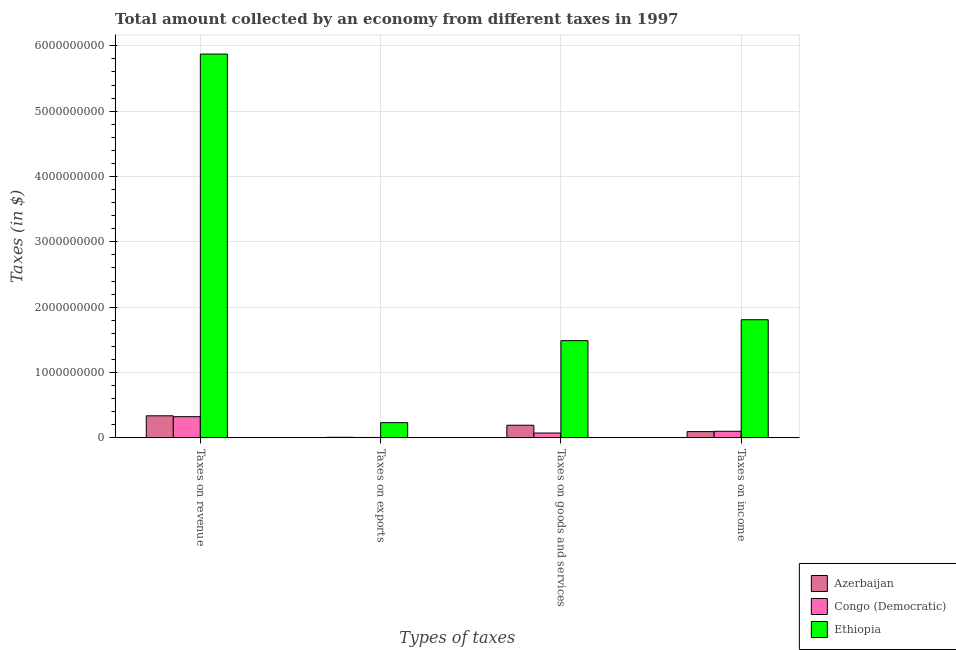How many different coloured bars are there?
Give a very brief answer. 3. Are the number of bars per tick equal to the number of legend labels?
Keep it short and to the point. Yes. Are the number of bars on each tick of the X-axis equal?
Your answer should be compact. Yes. How many bars are there on the 3rd tick from the right?
Your response must be concise. 3. What is the label of the 1st group of bars from the left?
Ensure brevity in your answer.  Taxes on revenue. What is the amount collected as tax on goods in Azerbaijan?
Give a very brief answer. 1.94e+08. Across all countries, what is the maximum amount collected as tax on income?
Make the answer very short. 1.81e+09. Across all countries, what is the minimum amount collected as tax on revenue?
Make the answer very short. 3.24e+08. In which country was the amount collected as tax on revenue maximum?
Ensure brevity in your answer.  Ethiopia. In which country was the amount collected as tax on exports minimum?
Offer a very short reply. Congo (Democratic). What is the total amount collected as tax on goods in the graph?
Provide a short and direct response. 1.76e+09. What is the difference between the amount collected as tax on revenue in Congo (Democratic) and that in Ethiopia?
Your answer should be compact. -5.55e+09. What is the difference between the amount collected as tax on goods in Azerbaijan and the amount collected as tax on exports in Ethiopia?
Your answer should be compact. -3.91e+07. What is the average amount collected as tax on goods per country?
Offer a terse response. 5.85e+08. What is the difference between the amount collected as tax on revenue and amount collected as tax on income in Ethiopia?
Provide a short and direct response. 4.07e+09. In how many countries, is the amount collected as tax on exports greater than 3600000000 $?
Keep it short and to the point. 0. What is the ratio of the amount collected as tax on income in Azerbaijan to that in Congo (Democratic)?
Ensure brevity in your answer.  0.95. Is the amount collected as tax on goods in Congo (Democratic) less than that in Azerbaijan?
Provide a short and direct response. Yes. What is the difference between the highest and the second highest amount collected as tax on goods?
Ensure brevity in your answer.  1.29e+09. What is the difference between the highest and the lowest amount collected as tax on exports?
Provide a short and direct response. 2.26e+08. Is the sum of the amount collected as tax on goods in Congo (Democratic) and Azerbaijan greater than the maximum amount collected as tax on exports across all countries?
Your response must be concise. Yes. Is it the case that in every country, the sum of the amount collected as tax on income and amount collected as tax on revenue is greater than the sum of amount collected as tax on exports and amount collected as tax on goods?
Provide a succinct answer. Yes. What does the 2nd bar from the left in Taxes on goods and services represents?
Your response must be concise. Congo (Democratic). What does the 2nd bar from the right in Taxes on exports represents?
Ensure brevity in your answer.  Congo (Democratic). How many bars are there?
Make the answer very short. 12. Does the graph contain any zero values?
Your response must be concise. No. What is the title of the graph?
Ensure brevity in your answer.  Total amount collected by an economy from different taxes in 1997. Does "Mongolia" appear as one of the legend labels in the graph?
Offer a very short reply. No. What is the label or title of the X-axis?
Provide a short and direct response. Types of taxes. What is the label or title of the Y-axis?
Offer a terse response. Taxes (in $). What is the Taxes (in $) of Azerbaijan in Taxes on revenue?
Your answer should be very brief. 3.38e+08. What is the Taxes (in $) of Congo (Democratic) in Taxes on revenue?
Your response must be concise. 3.24e+08. What is the Taxes (in $) in Ethiopia in Taxes on revenue?
Offer a terse response. 5.87e+09. What is the Taxes (in $) of Azerbaijan in Taxes on exports?
Give a very brief answer. 9.16e+06. What is the Taxes (in $) in Congo (Democratic) in Taxes on exports?
Ensure brevity in your answer.  6.24e+06. What is the Taxes (in $) of Ethiopia in Taxes on exports?
Make the answer very short. 2.33e+08. What is the Taxes (in $) in Azerbaijan in Taxes on goods and services?
Your answer should be compact. 1.94e+08. What is the Taxes (in $) of Congo (Democratic) in Taxes on goods and services?
Offer a very short reply. 7.41e+07. What is the Taxes (in $) of Ethiopia in Taxes on goods and services?
Your answer should be compact. 1.49e+09. What is the Taxes (in $) in Azerbaijan in Taxes on income?
Make the answer very short. 9.60e+07. What is the Taxes (in $) in Congo (Democratic) in Taxes on income?
Your answer should be compact. 1.01e+08. What is the Taxes (in $) in Ethiopia in Taxes on income?
Your answer should be compact. 1.81e+09. Across all Types of taxes, what is the maximum Taxes (in $) of Azerbaijan?
Keep it short and to the point. 3.38e+08. Across all Types of taxes, what is the maximum Taxes (in $) in Congo (Democratic)?
Give a very brief answer. 3.24e+08. Across all Types of taxes, what is the maximum Taxes (in $) in Ethiopia?
Your answer should be very brief. 5.87e+09. Across all Types of taxes, what is the minimum Taxes (in $) in Azerbaijan?
Provide a succinct answer. 9.16e+06. Across all Types of taxes, what is the minimum Taxes (in $) in Congo (Democratic)?
Provide a succinct answer. 6.24e+06. Across all Types of taxes, what is the minimum Taxes (in $) in Ethiopia?
Your answer should be very brief. 2.33e+08. What is the total Taxes (in $) in Azerbaijan in the graph?
Make the answer very short. 6.36e+08. What is the total Taxes (in $) of Congo (Democratic) in the graph?
Make the answer very short. 5.05e+08. What is the total Taxes (in $) of Ethiopia in the graph?
Provide a short and direct response. 9.40e+09. What is the difference between the Taxes (in $) of Azerbaijan in Taxes on revenue and that in Taxes on exports?
Your response must be concise. 3.29e+08. What is the difference between the Taxes (in $) in Congo (Democratic) in Taxes on revenue and that in Taxes on exports?
Your response must be concise. 3.18e+08. What is the difference between the Taxes (in $) of Ethiopia in Taxes on revenue and that in Taxes on exports?
Provide a succinct answer. 5.64e+09. What is the difference between the Taxes (in $) of Azerbaijan in Taxes on revenue and that in Taxes on goods and services?
Provide a short and direct response. 1.44e+08. What is the difference between the Taxes (in $) of Congo (Democratic) in Taxes on revenue and that in Taxes on goods and services?
Ensure brevity in your answer.  2.50e+08. What is the difference between the Taxes (in $) of Ethiopia in Taxes on revenue and that in Taxes on goods and services?
Your response must be concise. 4.39e+09. What is the difference between the Taxes (in $) of Azerbaijan in Taxes on revenue and that in Taxes on income?
Make the answer very short. 2.42e+08. What is the difference between the Taxes (in $) in Congo (Democratic) in Taxes on revenue and that in Taxes on income?
Your answer should be compact. 2.24e+08. What is the difference between the Taxes (in $) of Ethiopia in Taxes on revenue and that in Taxes on income?
Keep it short and to the point. 4.07e+09. What is the difference between the Taxes (in $) of Azerbaijan in Taxes on exports and that in Taxes on goods and services?
Your answer should be very brief. -1.84e+08. What is the difference between the Taxes (in $) of Congo (Democratic) in Taxes on exports and that in Taxes on goods and services?
Provide a succinct answer. -6.78e+07. What is the difference between the Taxes (in $) of Ethiopia in Taxes on exports and that in Taxes on goods and services?
Ensure brevity in your answer.  -1.26e+09. What is the difference between the Taxes (in $) in Azerbaijan in Taxes on exports and that in Taxes on income?
Offer a terse response. -8.68e+07. What is the difference between the Taxes (in $) in Congo (Democratic) in Taxes on exports and that in Taxes on income?
Provide a short and direct response. -9.44e+07. What is the difference between the Taxes (in $) in Ethiopia in Taxes on exports and that in Taxes on income?
Make the answer very short. -1.58e+09. What is the difference between the Taxes (in $) of Azerbaijan in Taxes on goods and services and that in Taxes on income?
Make the answer very short. 9.75e+07. What is the difference between the Taxes (in $) in Congo (Democratic) in Taxes on goods and services and that in Taxes on income?
Your response must be concise. -2.66e+07. What is the difference between the Taxes (in $) in Ethiopia in Taxes on goods and services and that in Taxes on income?
Your response must be concise. -3.20e+08. What is the difference between the Taxes (in $) in Azerbaijan in Taxes on revenue and the Taxes (in $) in Congo (Democratic) in Taxes on exports?
Ensure brevity in your answer.  3.32e+08. What is the difference between the Taxes (in $) in Azerbaijan in Taxes on revenue and the Taxes (in $) in Ethiopia in Taxes on exports?
Give a very brief answer. 1.05e+08. What is the difference between the Taxes (in $) in Congo (Democratic) in Taxes on revenue and the Taxes (in $) in Ethiopia in Taxes on exports?
Provide a succinct answer. 9.17e+07. What is the difference between the Taxes (in $) of Azerbaijan in Taxes on revenue and the Taxes (in $) of Congo (Democratic) in Taxes on goods and services?
Offer a terse response. 2.64e+08. What is the difference between the Taxes (in $) of Azerbaijan in Taxes on revenue and the Taxes (in $) of Ethiopia in Taxes on goods and services?
Provide a short and direct response. -1.15e+09. What is the difference between the Taxes (in $) of Congo (Democratic) in Taxes on revenue and the Taxes (in $) of Ethiopia in Taxes on goods and services?
Your answer should be compact. -1.16e+09. What is the difference between the Taxes (in $) of Azerbaijan in Taxes on revenue and the Taxes (in $) of Congo (Democratic) in Taxes on income?
Offer a very short reply. 2.37e+08. What is the difference between the Taxes (in $) of Azerbaijan in Taxes on revenue and the Taxes (in $) of Ethiopia in Taxes on income?
Ensure brevity in your answer.  -1.47e+09. What is the difference between the Taxes (in $) in Congo (Democratic) in Taxes on revenue and the Taxes (in $) in Ethiopia in Taxes on income?
Give a very brief answer. -1.48e+09. What is the difference between the Taxes (in $) of Azerbaijan in Taxes on exports and the Taxes (in $) of Congo (Democratic) in Taxes on goods and services?
Keep it short and to the point. -6.49e+07. What is the difference between the Taxes (in $) in Azerbaijan in Taxes on exports and the Taxes (in $) in Ethiopia in Taxes on goods and services?
Make the answer very short. -1.48e+09. What is the difference between the Taxes (in $) in Congo (Democratic) in Taxes on exports and the Taxes (in $) in Ethiopia in Taxes on goods and services?
Ensure brevity in your answer.  -1.48e+09. What is the difference between the Taxes (in $) of Azerbaijan in Taxes on exports and the Taxes (in $) of Congo (Democratic) in Taxes on income?
Keep it short and to the point. -9.15e+07. What is the difference between the Taxes (in $) of Azerbaijan in Taxes on exports and the Taxes (in $) of Ethiopia in Taxes on income?
Your answer should be compact. -1.80e+09. What is the difference between the Taxes (in $) in Congo (Democratic) in Taxes on exports and the Taxes (in $) in Ethiopia in Taxes on income?
Your answer should be compact. -1.80e+09. What is the difference between the Taxes (in $) of Azerbaijan in Taxes on goods and services and the Taxes (in $) of Congo (Democratic) in Taxes on income?
Ensure brevity in your answer.  9.28e+07. What is the difference between the Taxes (in $) of Azerbaijan in Taxes on goods and services and the Taxes (in $) of Ethiopia in Taxes on income?
Make the answer very short. -1.61e+09. What is the difference between the Taxes (in $) in Congo (Democratic) in Taxes on goods and services and the Taxes (in $) in Ethiopia in Taxes on income?
Your answer should be compact. -1.73e+09. What is the average Taxes (in $) in Azerbaijan per Types of taxes?
Keep it short and to the point. 1.59e+08. What is the average Taxes (in $) in Congo (Democratic) per Types of taxes?
Ensure brevity in your answer.  1.26e+08. What is the average Taxes (in $) of Ethiopia per Types of taxes?
Provide a succinct answer. 2.35e+09. What is the difference between the Taxes (in $) of Azerbaijan and Taxes (in $) of Congo (Democratic) in Taxes on revenue?
Provide a short and direct response. 1.34e+07. What is the difference between the Taxes (in $) in Azerbaijan and Taxes (in $) in Ethiopia in Taxes on revenue?
Your answer should be very brief. -5.54e+09. What is the difference between the Taxes (in $) of Congo (Democratic) and Taxes (in $) of Ethiopia in Taxes on revenue?
Provide a short and direct response. -5.55e+09. What is the difference between the Taxes (in $) in Azerbaijan and Taxes (in $) in Congo (Democratic) in Taxes on exports?
Offer a very short reply. 2.92e+06. What is the difference between the Taxes (in $) in Azerbaijan and Taxes (in $) in Ethiopia in Taxes on exports?
Provide a short and direct response. -2.23e+08. What is the difference between the Taxes (in $) in Congo (Democratic) and Taxes (in $) in Ethiopia in Taxes on exports?
Provide a succinct answer. -2.26e+08. What is the difference between the Taxes (in $) in Azerbaijan and Taxes (in $) in Congo (Democratic) in Taxes on goods and services?
Keep it short and to the point. 1.19e+08. What is the difference between the Taxes (in $) of Azerbaijan and Taxes (in $) of Ethiopia in Taxes on goods and services?
Give a very brief answer. -1.29e+09. What is the difference between the Taxes (in $) of Congo (Democratic) and Taxes (in $) of Ethiopia in Taxes on goods and services?
Provide a short and direct response. -1.41e+09. What is the difference between the Taxes (in $) in Azerbaijan and Taxes (in $) in Congo (Democratic) in Taxes on income?
Offer a very short reply. -4.70e+06. What is the difference between the Taxes (in $) of Azerbaijan and Taxes (in $) of Ethiopia in Taxes on income?
Give a very brief answer. -1.71e+09. What is the difference between the Taxes (in $) of Congo (Democratic) and Taxes (in $) of Ethiopia in Taxes on income?
Make the answer very short. -1.71e+09. What is the ratio of the Taxes (in $) of Azerbaijan in Taxes on revenue to that in Taxes on exports?
Ensure brevity in your answer.  36.85. What is the ratio of the Taxes (in $) of Congo (Democratic) in Taxes on revenue to that in Taxes on exports?
Ensure brevity in your answer.  51.97. What is the ratio of the Taxes (in $) in Ethiopia in Taxes on revenue to that in Taxes on exports?
Your answer should be very brief. 25.25. What is the ratio of the Taxes (in $) in Azerbaijan in Taxes on revenue to that in Taxes on goods and services?
Keep it short and to the point. 1.75. What is the ratio of the Taxes (in $) of Congo (Democratic) in Taxes on revenue to that in Taxes on goods and services?
Your answer should be very brief. 4.38. What is the ratio of the Taxes (in $) in Ethiopia in Taxes on revenue to that in Taxes on goods and services?
Give a very brief answer. 3.95. What is the ratio of the Taxes (in $) of Azerbaijan in Taxes on revenue to that in Taxes on income?
Offer a very short reply. 3.52. What is the ratio of the Taxes (in $) of Congo (Democratic) in Taxes on revenue to that in Taxes on income?
Your response must be concise. 3.22. What is the ratio of the Taxes (in $) of Ethiopia in Taxes on revenue to that in Taxes on income?
Offer a terse response. 3.25. What is the ratio of the Taxes (in $) in Azerbaijan in Taxes on exports to that in Taxes on goods and services?
Offer a terse response. 0.05. What is the ratio of the Taxes (in $) in Congo (Democratic) in Taxes on exports to that in Taxes on goods and services?
Your response must be concise. 0.08. What is the ratio of the Taxes (in $) of Ethiopia in Taxes on exports to that in Taxes on goods and services?
Your response must be concise. 0.16. What is the ratio of the Taxes (in $) in Azerbaijan in Taxes on exports to that in Taxes on income?
Your response must be concise. 0.1. What is the ratio of the Taxes (in $) in Congo (Democratic) in Taxes on exports to that in Taxes on income?
Offer a very short reply. 0.06. What is the ratio of the Taxes (in $) of Ethiopia in Taxes on exports to that in Taxes on income?
Offer a very short reply. 0.13. What is the ratio of the Taxes (in $) in Azerbaijan in Taxes on goods and services to that in Taxes on income?
Your response must be concise. 2.02. What is the ratio of the Taxes (in $) of Congo (Democratic) in Taxes on goods and services to that in Taxes on income?
Keep it short and to the point. 0.74. What is the ratio of the Taxes (in $) in Ethiopia in Taxes on goods and services to that in Taxes on income?
Keep it short and to the point. 0.82. What is the difference between the highest and the second highest Taxes (in $) in Azerbaijan?
Offer a very short reply. 1.44e+08. What is the difference between the highest and the second highest Taxes (in $) of Congo (Democratic)?
Offer a terse response. 2.24e+08. What is the difference between the highest and the second highest Taxes (in $) of Ethiopia?
Your answer should be very brief. 4.07e+09. What is the difference between the highest and the lowest Taxes (in $) in Azerbaijan?
Give a very brief answer. 3.29e+08. What is the difference between the highest and the lowest Taxes (in $) of Congo (Democratic)?
Your response must be concise. 3.18e+08. What is the difference between the highest and the lowest Taxes (in $) in Ethiopia?
Your answer should be very brief. 5.64e+09. 